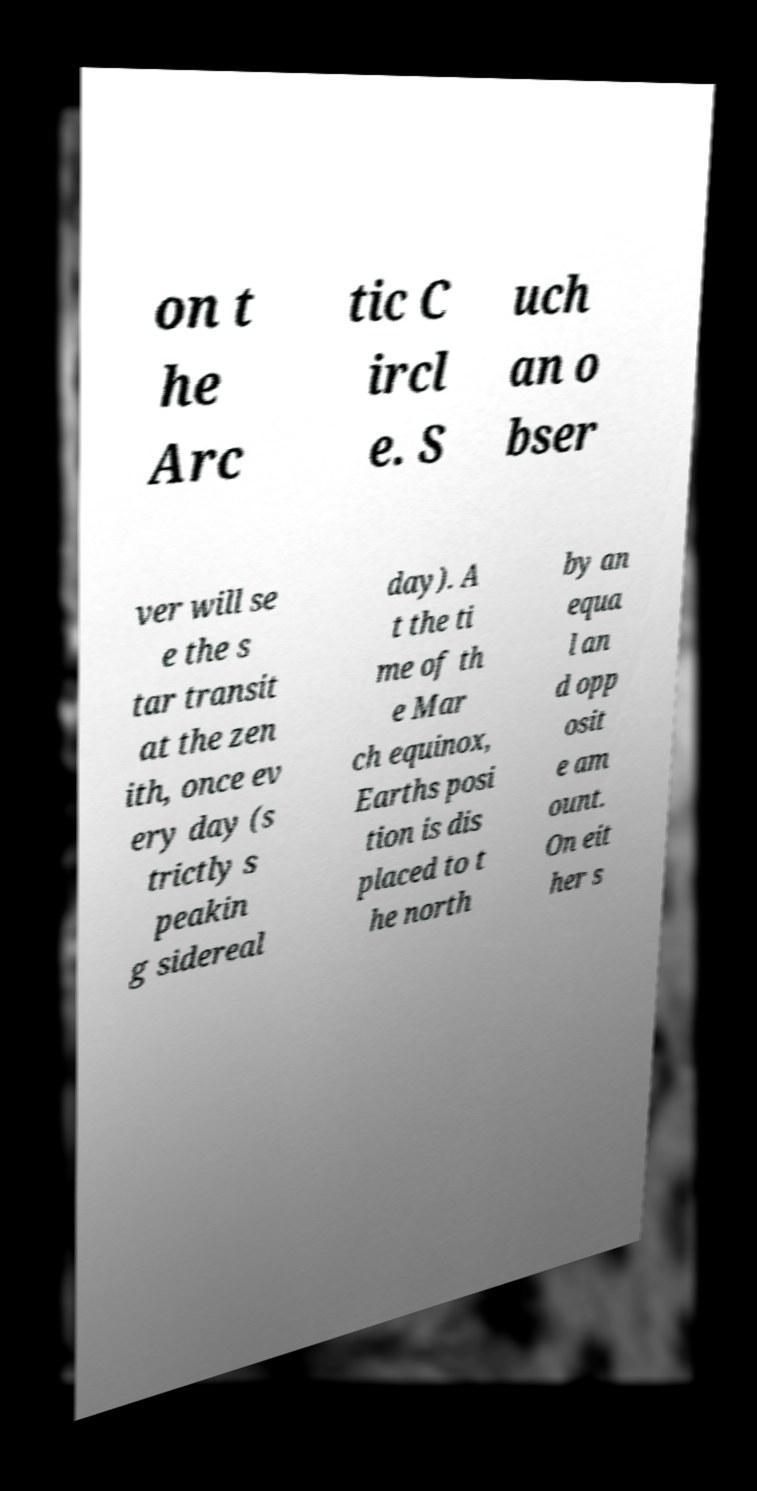There's text embedded in this image that I need extracted. Can you transcribe it verbatim? on t he Arc tic C ircl e. S uch an o bser ver will se e the s tar transit at the zen ith, once ev ery day (s trictly s peakin g sidereal day). A t the ti me of th e Mar ch equinox, Earths posi tion is dis placed to t he north by an equa l an d opp osit e am ount. On eit her s 